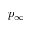<formula> <loc_0><loc_0><loc_500><loc_500>p _ { \infty }</formula> 